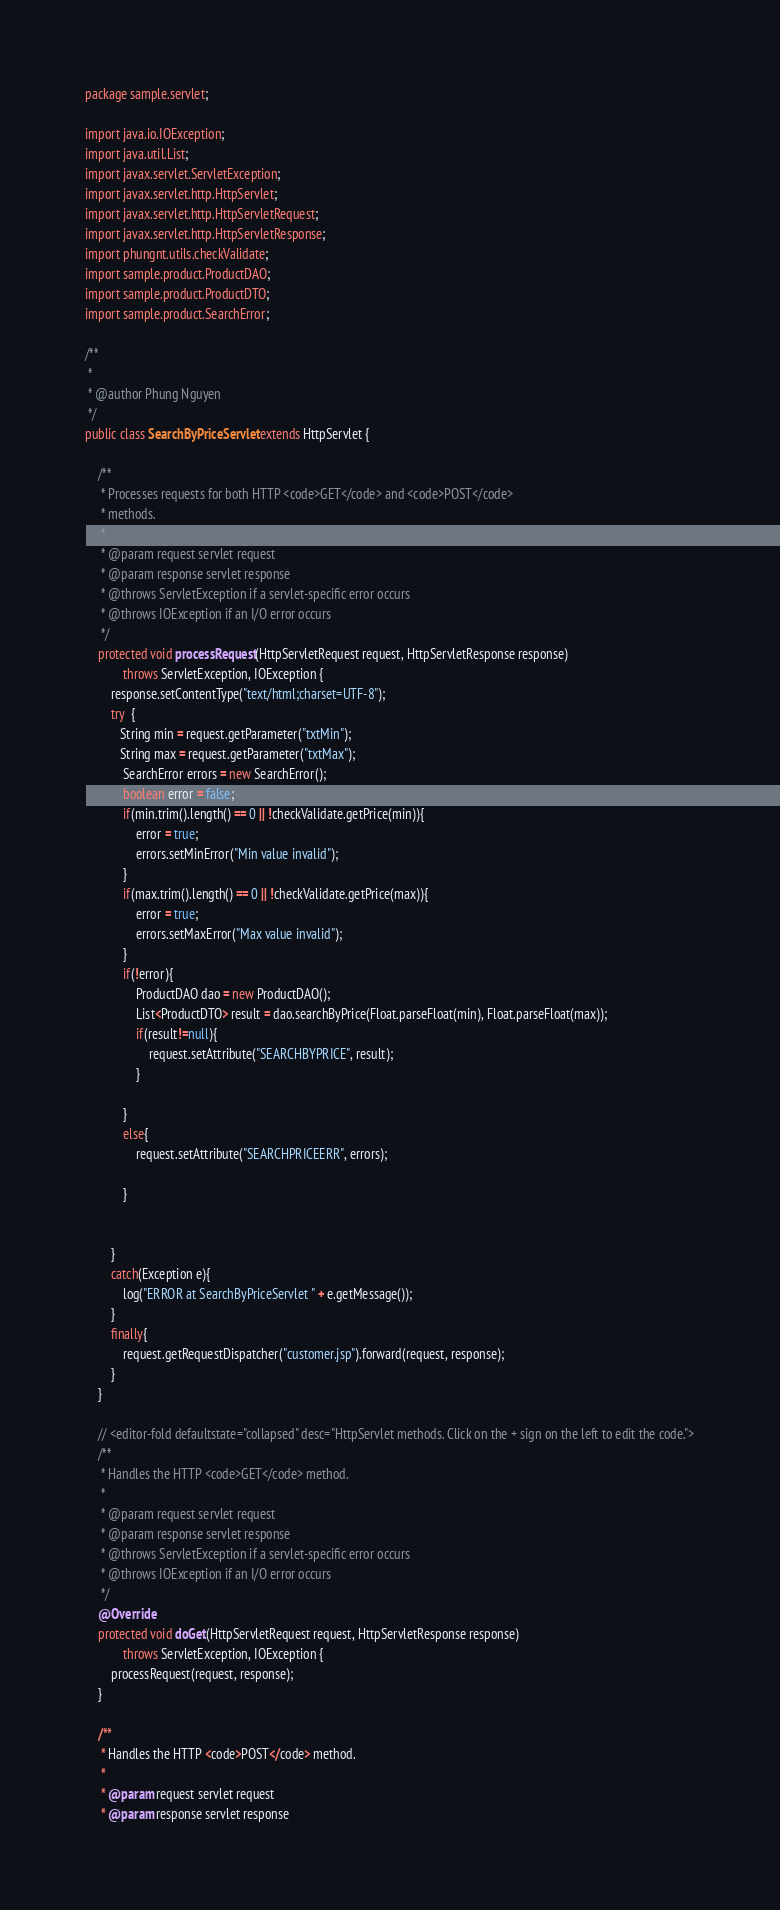Convert code to text. <code><loc_0><loc_0><loc_500><loc_500><_Java_>
package sample.servlet;

import java.io.IOException;
import java.util.List;
import javax.servlet.ServletException;
import javax.servlet.http.HttpServlet;
import javax.servlet.http.HttpServletRequest;
import javax.servlet.http.HttpServletResponse;
import phungnt.utils.checkValidate;
import sample.product.ProductDAO;
import sample.product.ProductDTO;
import sample.product.SearchError;

/**
 *
 * @author Phung Nguyen
 */
public class SearchByPriceServlet extends HttpServlet {

    /**
     * Processes requests for both HTTP <code>GET</code> and <code>POST</code>
     * methods.
     *
     * @param request servlet request
     * @param response servlet response
     * @throws ServletException if a servlet-specific error occurs
     * @throws IOException if an I/O error occurs
     */
    protected void processRequest(HttpServletRequest request, HttpServletResponse response)
            throws ServletException, IOException {
        response.setContentType("text/html;charset=UTF-8");
        try  {
           String min = request.getParameter("txtMin");
           String max = request.getParameter("txtMax");
            SearchError errors = new SearchError();
            boolean error = false;
            if(min.trim().length() == 0 || !checkValidate.getPrice(min)){
                error = true;
                errors.setMinError("Min value invalid");
            }
            if(max.trim().length() == 0 || !checkValidate.getPrice(max)){
                error = true;
                errors.setMaxError("Max value invalid");
            }
            if(!error){
                ProductDAO dao = new ProductDAO();
                List<ProductDTO> result = dao.searchByPrice(Float.parseFloat(min), Float.parseFloat(max));
                if(result!=null){
                    request.setAttribute("SEARCHBYPRICE", result);
                }
                
            }
            else{
                request.setAttribute("SEARCHPRICEERR", errors);
                
            }
           
           
        }
        catch(Exception e){
            log("ERROR at SearchByPriceServlet " + e.getMessage());
        }
        finally{
            request.getRequestDispatcher("customer.jsp").forward(request, response);
        }
    }

    // <editor-fold defaultstate="collapsed" desc="HttpServlet methods. Click on the + sign on the left to edit the code.">
    /**
     * Handles the HTTP <code>GET</code> method.
     *
     * @param request servlet request
     * @param response servlet response
     * @throws ServletException if a servlet-specific error occurs
     * @throws IOException if an I/O error occurs
     */
    @Override
    protected void doGet(HttpServletRequest request, HttpServletResponse response)
            throws ServletException, IOException {
        processRequest(request, response);
    }

    /**
     * Handles the HTTP <code>POST</code> method.
     *
     * @param request servlet request
     * @param response servlet response</code> 